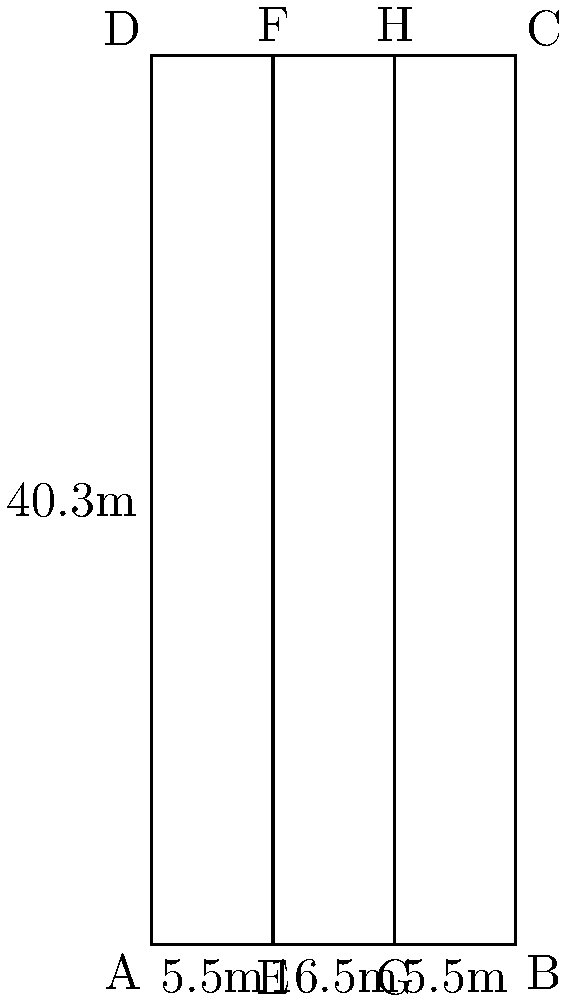As a soccer analyst developing predictive models, you're tasked with calculating the area of the penalty box. Given the coordinate system where point A is at (0,0), B is at (16.5,0), C is at (16.5,40.3), and D is at (0,40.3), determine the area of the penalty box in square meters. How would this information be useful in your predictive modeling for team strategies? To calculate the area of the penalty box, we'll follow these steps:

1) Identify the shape: The penalty box is a rectangle.

2) Calculate the width:
   The width is the distance between points A and B.
   Width = $16.5$ meters

3) Calculate the length:
   The length is the distance between points A and D.
   Length = $40.3$ meters

4) Calculate the area:
   Area of a rectangle = width × length
   Area = $16.5 \times 40.3 = 665.95$ square meters

5) Relevance to predictive modeling and team strategies:
   - Space utilization: Understanding the area helps in analyzing how teams use the available space in the penalty box.
   - Player positioning: The dimensions can be used to optimize player positions for both attacking and defending strategies.
   - Shot analysis: Knowing the area aids in analyzing shot locations and probabilities within the penalty box.
   - Set-piece strategies: The dimensions are crucial for designing effective corner kicks, free kicks, and other set-pieces.
   - Defensive formations: The area information helps in organizing defensive lines and zonal marking systems.
   - Pressure analysis: It allows for quantifying defensive pressure in relation to the total area of the penalty box.
   - Movement patterns: The dimensions can be used to analyze and optimize player movement patterns in attacking and defending situations.

By incorporating this spatial information into predictive models, analysts can enhance team strategies, improve decision-making, and gain a competitive edge in both offensive and defensive play.
Answer: 665.95 square meters 